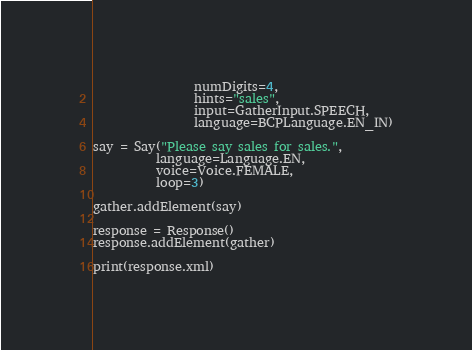Convert code to text. <code><loc_0><loc_0><loc_500><loc_500><_Python_>                numDigits=4,
                hints="sales",
                input=GatherInput.SPEECH,
                language=BCPLanguage.EN_IN)

say = Say("Please say sales for sales.",
          language=Language.EN,
          voice=Voice.FEMALE,
          loop=3)

gather.addElement(say)

response = Response()
response.addElement(gather)

print(response.xml)
</code> 